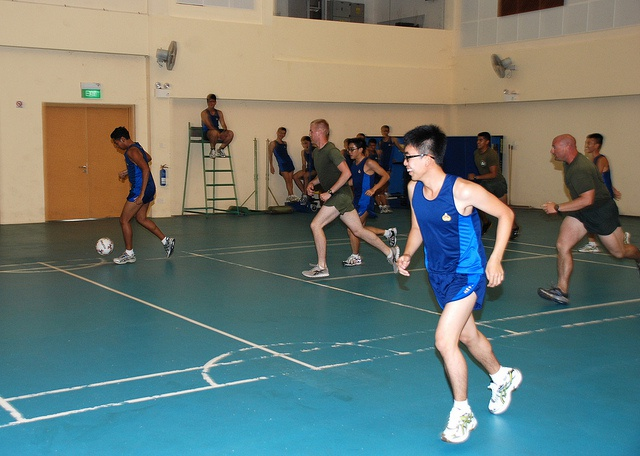Describe the objects in this image and their specific colors. I can see people in tan, white, blue, and darkblue tones, people in tan, black, brown, maroon, and gray tones, people in tan, black, brown, gray, and darkgray tones, people in tan, maroon, black, and navy tones, and people in tan, black, brown, and maroon tones in this image. 